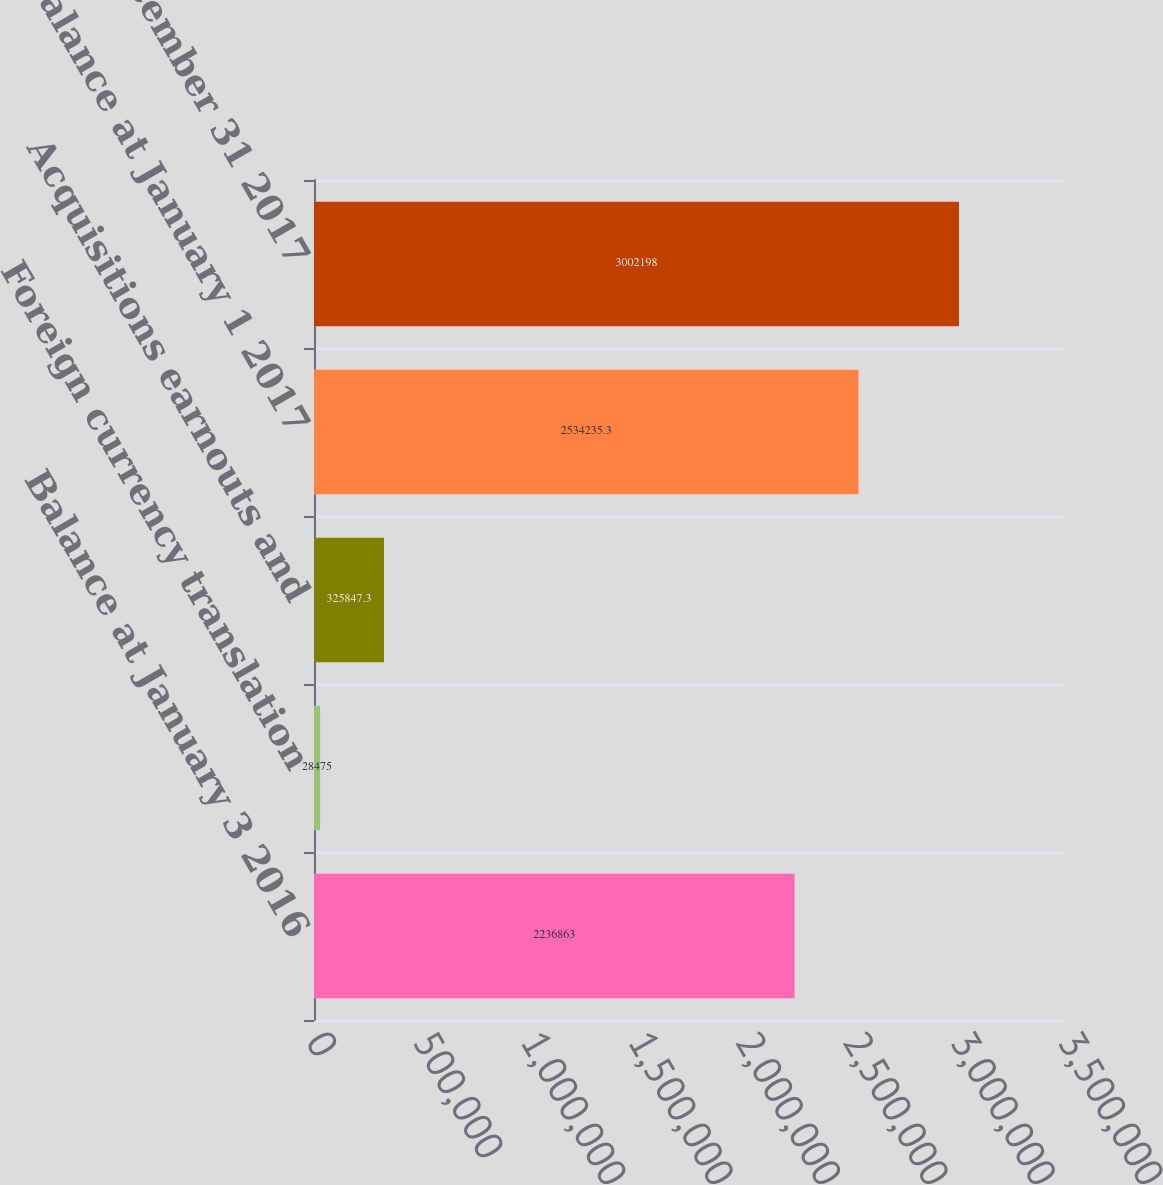Convert chart to OTSL. <chart><loc_0><loc_0><loc_500><loc_500><bar_chart><fcel>Balance at January 3 2016<fcel>Foreign currency translation<fcel>Acquisitions earnouts and<fcel>Balance at January 1 2017<fcel>Balance at December 31 2017<nl><fcel>2.23686e+06<fcel>28475<fcel>325847<fcel>2.53424e+06<fcel>3.0022e+06<nl></chart> 